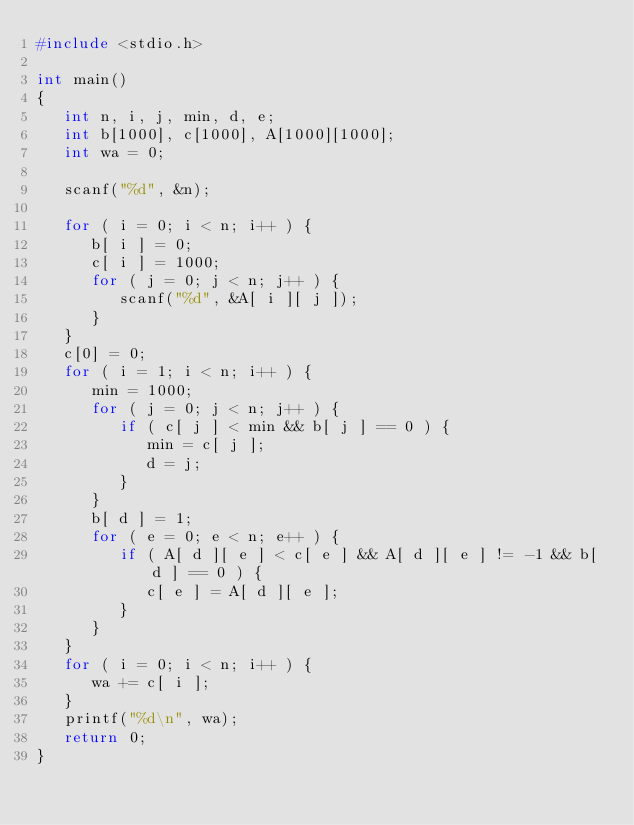<code> <loc_0><loc_0><loc_500><loc_500><_C_>#include <stdio.h>

int main()
{
   int n, i, j, min, d, e;
   int b[1000], c[1000], A[1000][1000];
   int wa = 0;

   scanf("%d", &n);

   for ( i = 0; i < n; i++ ) {
      b[ i ] = 0;
      c[ i ] = 1000;
      for ( j = 0; j < n; j++ ) {
         scanf("%d", &A[ i ][ j ]);
      }
   }
   c[0] = 0;
   for ( i = 1; i < n; i++ ) {
      min = 1000;
      for ( j = 0; j < n; j++ ) {
         if ( c[ j ] < min && b[ j ] == 0 ) {
            min = c[ j ];
            d = j;
         }
      }
      b[ d ] = 1;
      for ( e = 0; e < n; e++ ) {
         if ( A[ d ][ e ] < c[ e ] && A[ d ][ e ] != -1 && b[ d ] == 0 ) {
            c[ e ] = A[ d ][ e ];
         }
      }
   }
   for ( i = 0; i < n; i++ ) {
      wa += c[ i ];
   }
   printf("%d\n", wa);
   return 0;
}</code> 